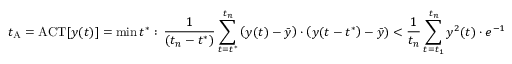<formula> <loc_0><loc_0><loc_500><loc_500>t _ { A } = A C T [ y ( t ) ] = \min \, t ^ { \ast } \colon \, \frac { 1 } { ( t _ { n } - t ^ { \ast } ) } \sum _ { t = t ^ { \ast } } ^ { t _ { n } } \left ( y ( t ) - \bar { y } \right ) \cdot \left ( y ( t - t ^ { \ast } \right ) - \bar { y } ) < \frac { 1 } { t _ { n } } \sum _ { t = t _ { 1 } } ^ { t _ { n } } y ^ { 2 } ( t ) \cdot e ^ { - 1 }</formula> 